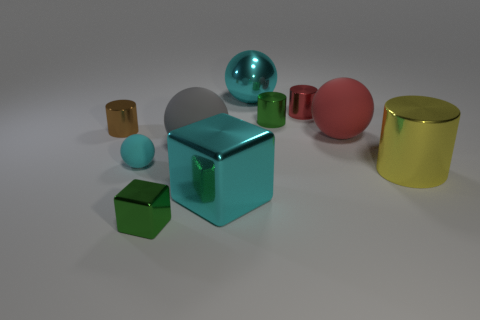Subtract all spheres. How many objects are left? 6 Add 8 small blue matte cylinders. How many small blue matte cylinders exist? 8 Subtract 0 purple blocks. How many objects are left? 10 Subtract all tiny rubber cubes. Subtract all tiny red shiny cylinders. How many objects are left? 9 Add 9 yellow metallic cylinders. How many yellow metallic cylinders are left? 10 